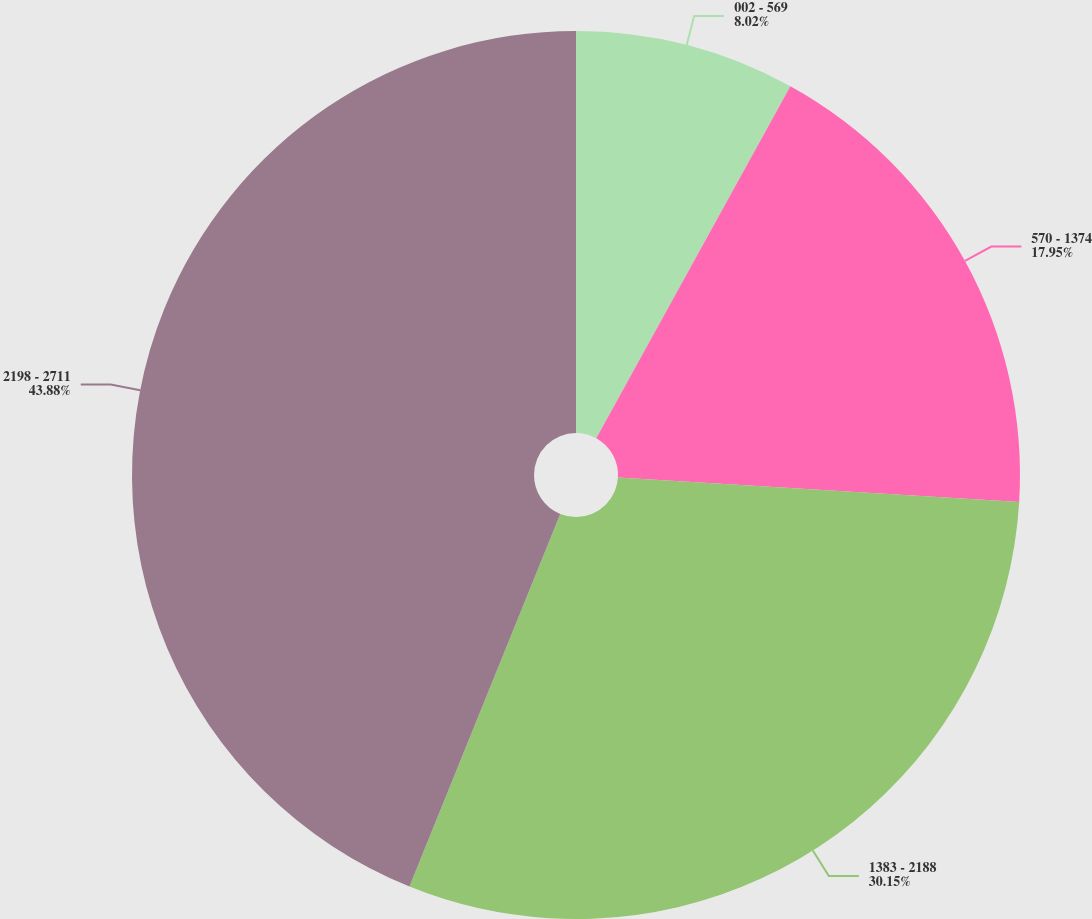<chart> <loc_0><loc_0><loc_500><loc_500><pie_chart><fcel>002 - 569<fcel>570 - 1374<fcel>1383 - 2188<fcel>2198 - 2711<nl><fcel>8.02%<fcel>17.95%<fcel>30.15%<fcel>43.88%<nl></chart> 